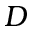<formula> <loc_0><loc_0><loc_500><loc_500>D</formula> 